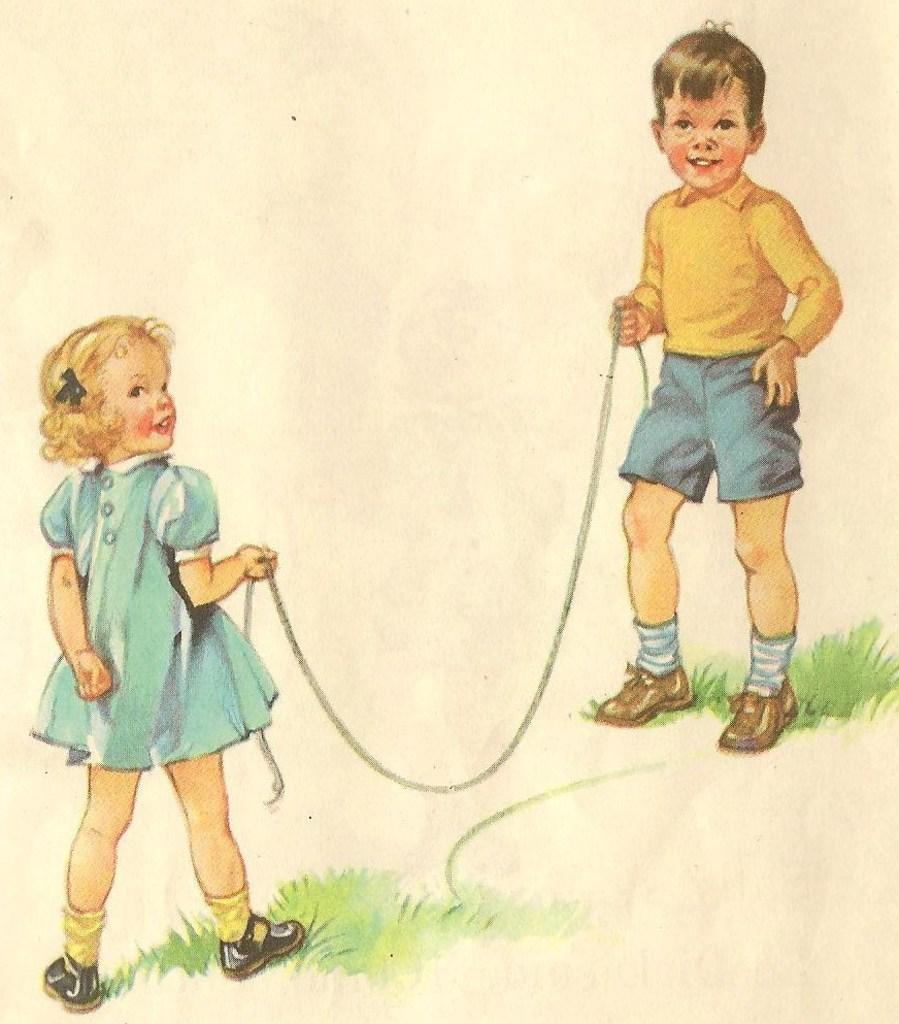What is the main subject of the image? There is a painting in the image. What is happening in the painting? The painting depicts two children holding a rope. What type of surface is visible beneath the children in the painting? There is grass on the ground in the image. What type of bone can be seen in the painting? There is no bone present in the painting. 